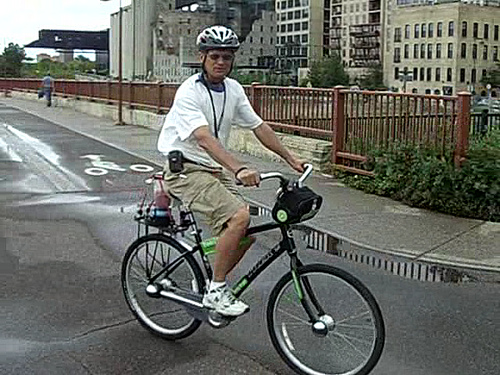What type of area is the man biking in? The man is biking in what seems to be an urban area, likely a designated bike lane given the road markings. The surroundings hint at a developed city infrastructure with buildings in the background that suggest a downtown or residential area intermingled with commercial spaces. 